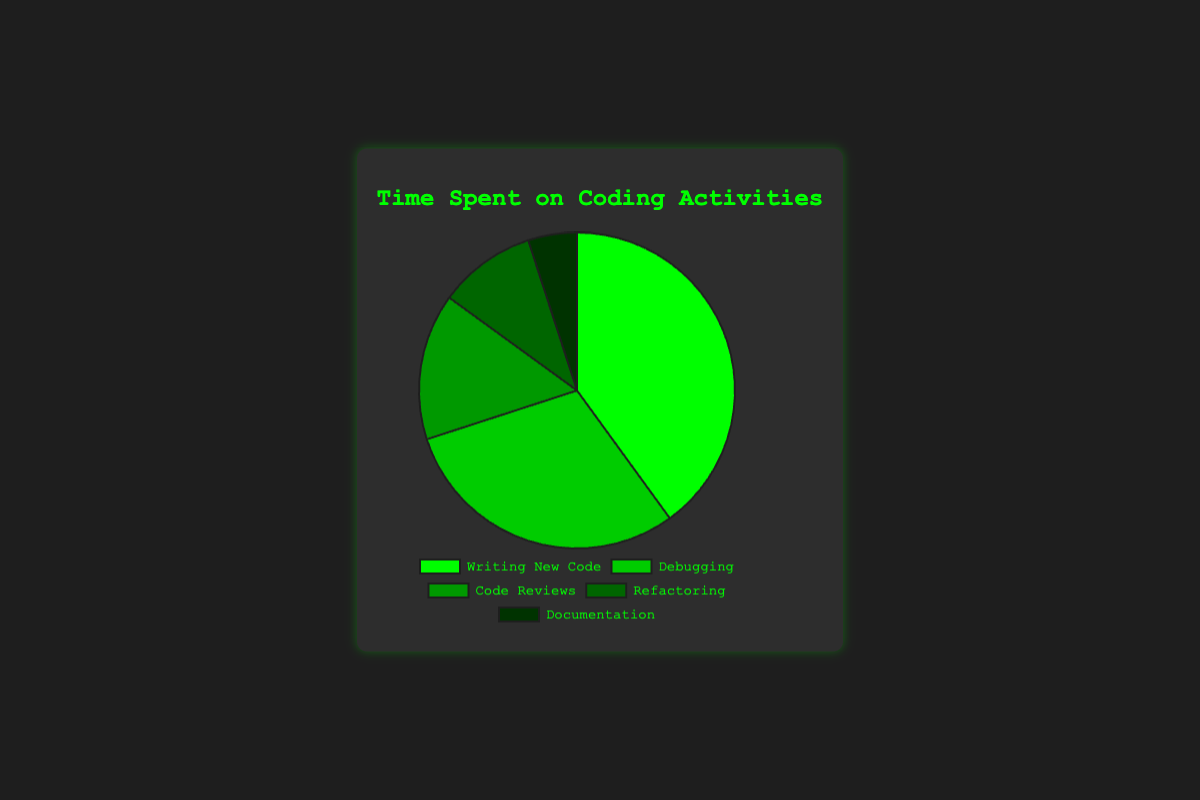What activity takes up the largest proportion of time spent on coding activities? The pie chart shows that "Writing New Code" occupies 40% of the total time spent on coding activities, which is the largest proportion compared to the other activities.
Answer: Writing New Code Which activity takes up the smallest proportion of time spent on coding activities? The pie chart shows that "Documentation" occupies only 5% of the total time spent on coding activities, which is the smallest proportion compared to the other activities.
Answer: Documentation How much more time percentage is spent on "Debugging" compared to "Refactoring"? The time spent on "Debugging" is 30%, and the time spent on "Refactoring" is 10%. The difference between them is 30% - 10% = 20%.
Answer: 20% What is the total percentage of time spent on "Code Reviews" and "Documentation" combined? Adding the percentages for "Code Reviews" (15%) and "Documentation" (5%) results in a total of 20%.
Answer: 20% Which activities together take up exactly half of the total time spent on coding activities? The activities "Debugging" (30%) and "Documentation" (5%) together do not sum up to half. However, "Writing New Code" (40%), "Code Reviews" (15%), and "Refactoring" (10%) sum to 65%, splitting the most considerable and remaining amounts equally. Check again: adding "Writing New Code" (40%) and "Debugging" (30%) makes up 70%. Correctly, there isn't a straightforward 50% in the data intervals provided meaningfully.
Answer: No exact divide Which activity occupies the chart segment represented by the darkest green color? The pie chart shows the darkest green color corresponding to the activity with the smallest proportion, which is "Documentation".
Answer: Documentation What combined percentage of time is spent on activities other than writing new code? The total time spent on activities other than "Writing New Code" is calculated by adding the percentages of "Debugging" (30%), "Code Reviews" (15%), "Refactoring" (10%), and "Documentation" (5%). Thus, the combined percentage is 30% + 15% + 10% + 5% = 60%.
Answer: 60% How many activities together make up more than 50% of the total time? To find the minimum number of activities that together make up more than 50% of the total time, start with the largest proportions. "Writing New Code" is 40%, adding "Debugging" takes it to 70%. Just these two activities alone already exceed 50%. So, the answer is 2 activities.
Answer: 2 activities What is the average percentage of time spent on "Code Reviews", "Refactoring", and "Documentation"? The percentages for "Code Reviews" is 15%, "Refactoring" is 10%, and "Documentation" is 5%. The average is calculated as (15 + 10 + 5) / 3 = 10%.
Answer: 10% 